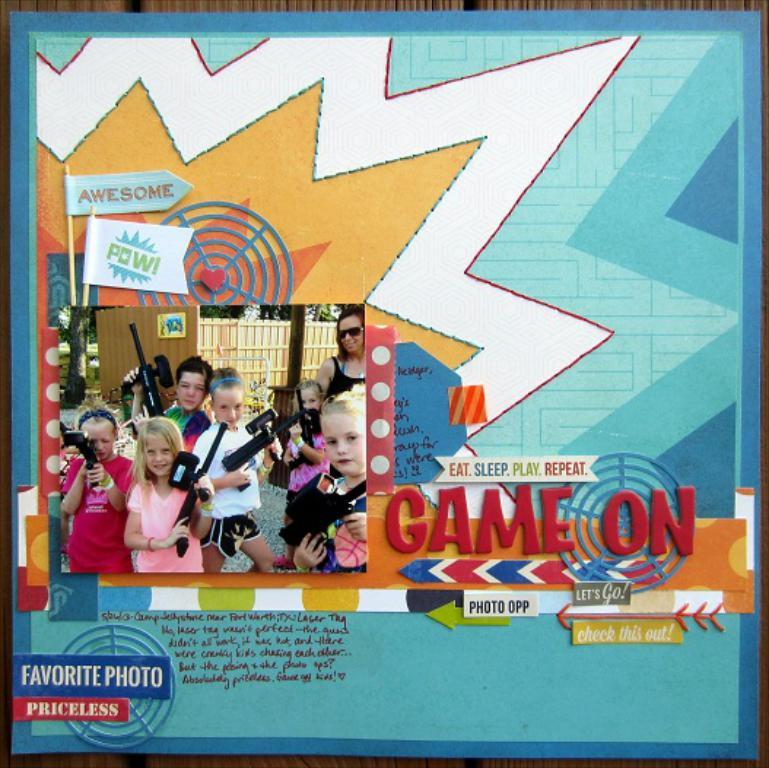What type of visual content is the image? The image is a poster. What is depicted on the poster? There is a group of kids in the poster. What are the kids doing in the poster? The kids are standing and holding weapons in their hands. What else can be seen on the poster besides the kids? There are letters on the poster, and it has a design. Can you tell me what type of note the kids are passing to each other in the poster? There is no note being passed between the kids in the poster; they are holding weapons. What kind of iron is being used by the kids to create the weapons in the poster? There is no iron visible in the poster, and the weapons are not being forged in the image. 